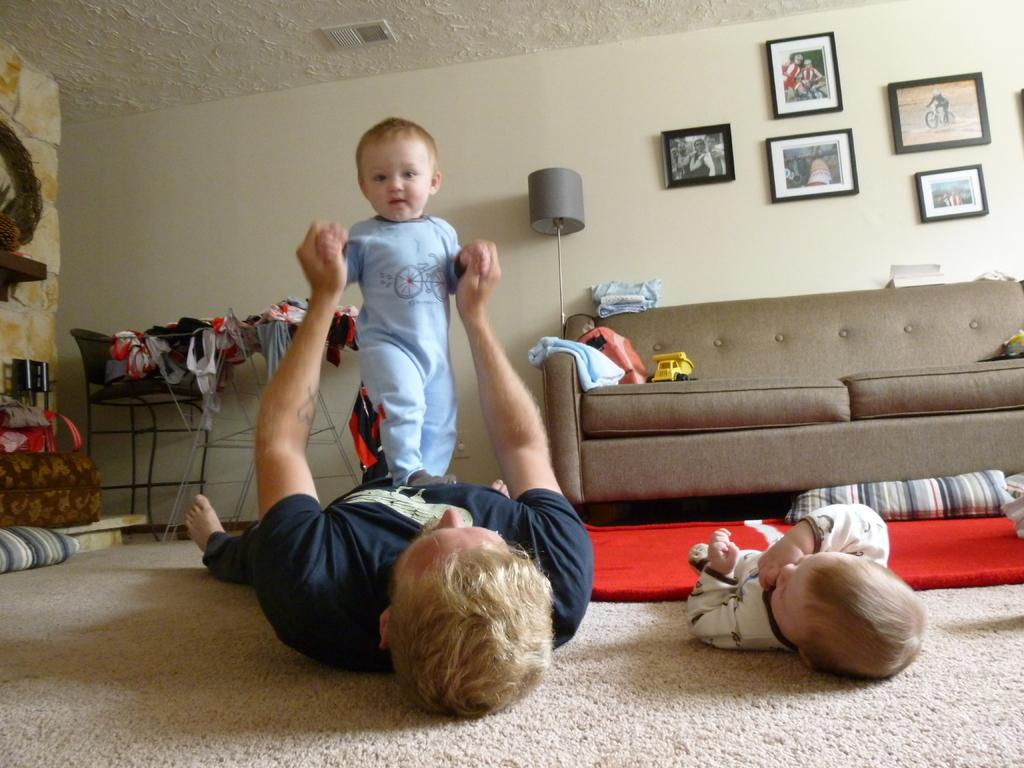Who is present in the image? There is a man and two boys in the image. What are the boys doing in the image? One boy is lying on the floor, and the other boy is standing on the man. What type of furniture is in the image? There is a sofa in the image. What can be seen on the wall in the image? There are photo frames on the wall in the image. What else can be seen in the image? There are clothes visible in the image. Can you see any dinosaurs at the seashore in the image? There are no dinosaurs or seashore present in the image. 